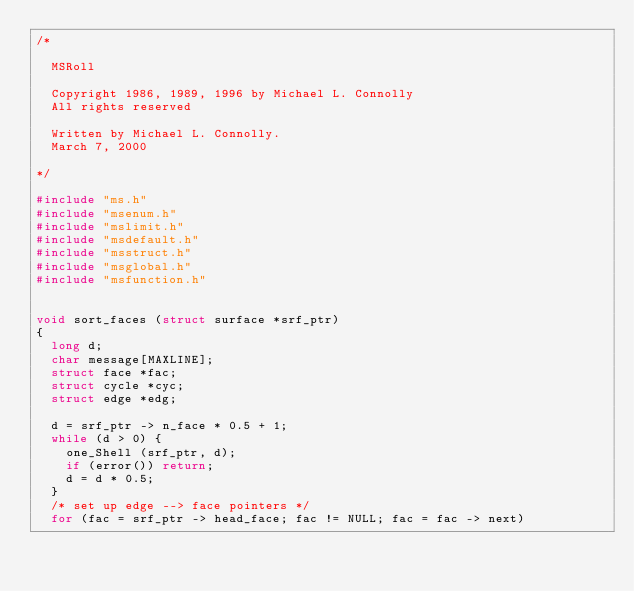Convert code to text. <code><loc_0><loc_0><loc_500><loc_500><_C_>/*

	MSRoll

	Copyright 1986, 1989, 1996 by Michael L. Connolly
	All rights reserved

	Written by Michael L. Connolly.
	March 7, 2000

*/

#include "ms.h"
#include "msenum.h"
#include "mslimit.h"
#include "msdefault.h"
#include "msstruct.h"
#include "msglobal.h"
#include "msfunction.h"


void sort_faces (struct surface *srf_ptr)
{
	long d;
	char message[MAXLINE];
	struct face *fac;
	struct cycle *cyc;
	struct edge *edg;
	
	d = srf_ptr -> n_face * 0.5 + 1;
	while (d > 0) {
		one_Shell (srf_ptr, d);
		if (error()) return;
		d = d * 0.5;
	}
	/* set up edge --> face pointers */
	for (fac = srf_ptr -> head_face; fac != NULL; fac = fac -> next)</code> 